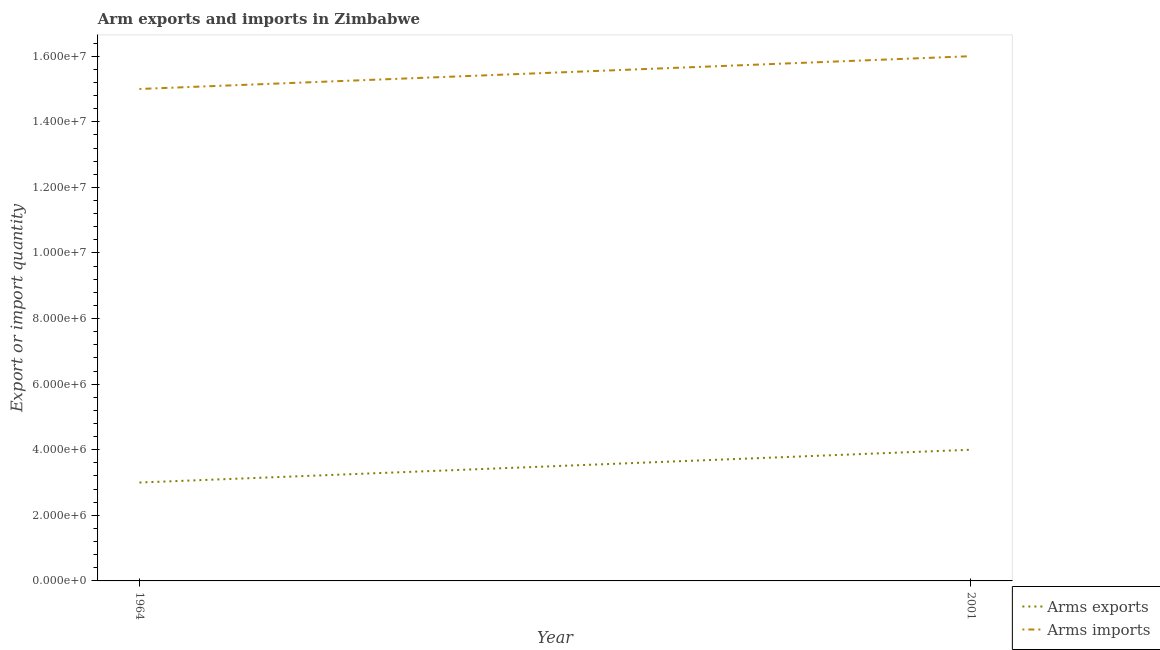How many different coloured lines are there?
Make the answer very short. 2. Is the number of lines equal to the number of legend labels?
Your response must be concise. Yes. What is the arms exports in 2001?
Your answer should be compact. 4.00e+06. Across all years, what is the maximum arms exports?
Offer a very short reply. 4.00e+06. Across all years, what is the minimum arms imports?
Provide a short and direct response. 1.50e+07. In which year was the arms imports maximum?
Give a very brief answer. 2001. In which year was the arms imports minimum?
Keep it short and to the point. 1964. What is the total arms imports in the graph?
Your answer should be very brief. 3.10e+07. What is the difference between the arms exports in 1964 and that in 2001?
Provide a succinct answer. -1.00e+06. What is the difference between the arms exports in 1964 and the arms imports in 2001?
Keep it short and to the point. -1.30e+07. What is the average arms imports per year?
Offer a terse response. 1.55e+07. In the year 2001, what is the difference between the arms exports and arms imports?
Offer a terse response. -1.20e+07. In how many years, is the arms imports greater than 8000000?
Provide a succinct answer. 2. What is the ratio of the arms imports in 1964 to that in 2001?
Provide a short and direct response. 0.94. Does the arms imports monotonically increase over the years?
Keep it short and to the point. Yes. How many lines are there?
Your answer should be compact. 2. How many years are there in the graph?
Your answer should be compact. 2. Does the graph contain any zero values?
Provide a succinct answer. No. Does the graph contain grids?
Keep it short and to the point. No. Where does the legend appear in the graph?
Your answer should be very brief. Bottom right. How many legend labels are there?
Your answer should be very brief. 2. How are the legend labels stacked?
Provide a short and direct response. Vertical. What is the title of the graph?
Provide a short and direct response. Arm exports and imports in Zimbabwe. Does "Female population" appear as one of the legend labels in the graph?
Your answer should be compact. No. What is the label or title of the X-axis?
Provide a succinct answer. Year. What is the label or title of the Y-axis?
Provide a short and direct response. Export or import quantity. What is the Export or import quantity in Arms exports in 1964?
Ensure brevity in your answer.  3.00e+06. What is the Export or import quantity of Arms imports in 1964?
Provide a succinct answer. 1.50e+07. What is the Export or import quantity of Arms imports in 2001?
Your answer should be compact. 1.60e+07. Across all years, what is the maximum Export or import quantity in Arms exports?
Keep it short and to the point. 4.00e+06. Across all years, what is the maximum Export or import quantity of Arms imports?
Your answer should be compact. 1.60e+07. Across all years, what is the minimum Export or import quantity in Arms exports?
Offer a terse response. 3.00e+06. Across all years, what is the minimum Export or import quantity of Arms imports?
Your answer should be very brief. 1.50e+07. What is the total Export or import quantity in Arms imports in the graph?
Provide a succinct answer. 3.10e+07. What is the difference between the Export or import quantity of Arms exports in 1964 and the Export or import quantity of Arms imports in 2001?
Provide a short and direct response. -1.30e+07. What is the average Export or import quantity of Arms exports per year?
Make the answer very short. 3.50e+06. What is the average Export or import quantity in Arms imports per year?
Keep it short and to the point. 1.55e+07. In the year 1964, what is the difference between the Export or import quantity of Arms exports and Export or import quantity of Arms imports?
Provide a short and direct response. -1.20e+07. In the year 2001, what is the difference between the Export or import quantity in Arms exports and Export or import quantity in Arms imports?
Make the answer very short. -1.20e+07. What is the ratio of the Export or import quantity of Arms exports in 1964 to that in 2001?
Your answer should be compact. 0.75. What is the difference between the highest and the lowest Export or import quantity of Arms imports?
Your response must be concise. 1.00e+06. 